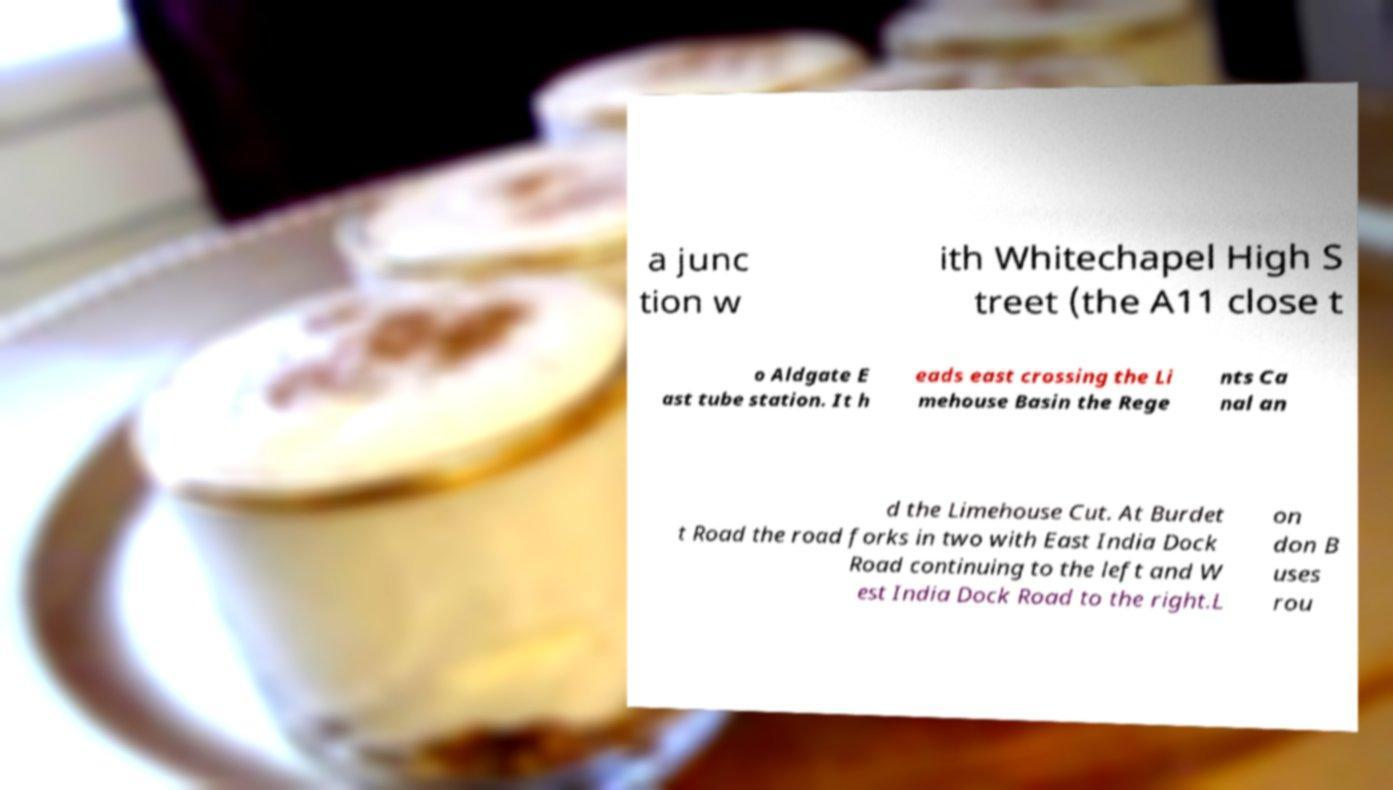Can you accurately transcribe the text from the provided image for me? a junc tion w ith Whitechapel High S treet (the A11 close t o Aldgate E ast tube station. It h eads east crossing the Li mehouse Basin the Rege nts Ca nal an d the Limehouse Cut. At Burdet t Road the road forks in two with East India Dock Road continuing to the left and W est India Dock Road to the right.L on don B uses rou 